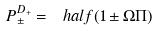Convert formula to latex. <formula><loc_0><loc_0><loc_500><loc_500>P _ { \pm } ^ { D _ { + } } = \ h a l f ( 1 \pm \Omega \Pi )</formula> 